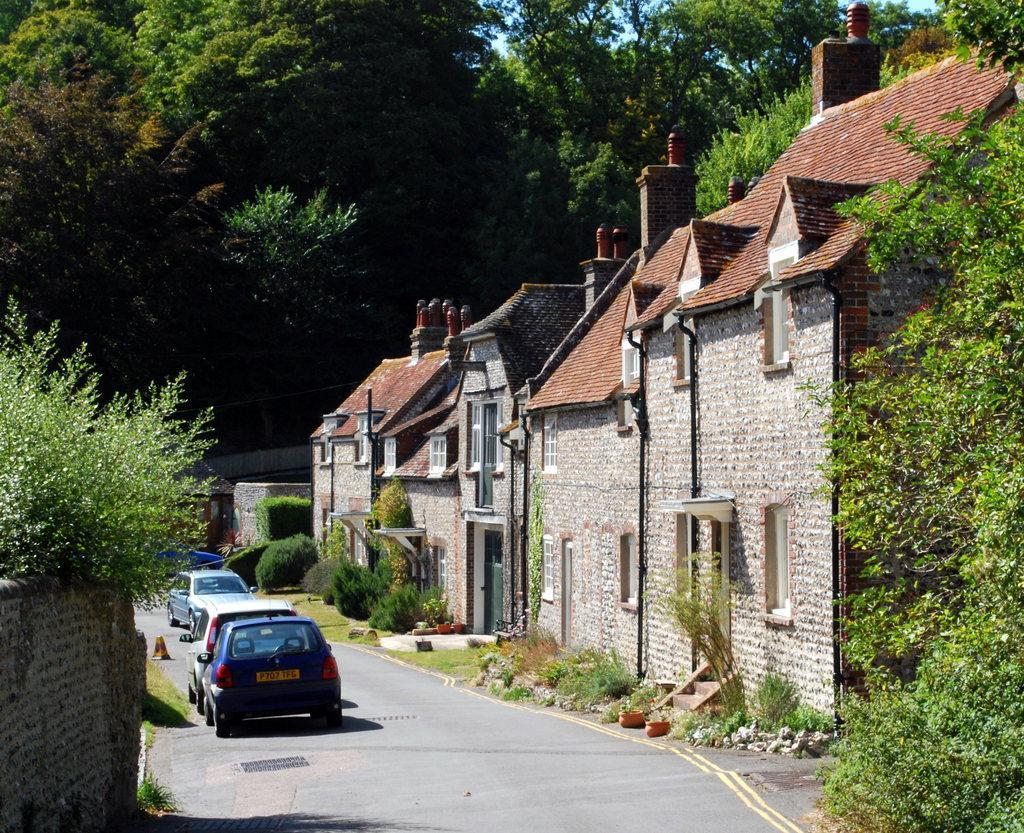Can you describe this image briefly? In this image we can see few houses. There are many trees and plants in the image. There are few vehicles on the road. There is a sky in the image. 